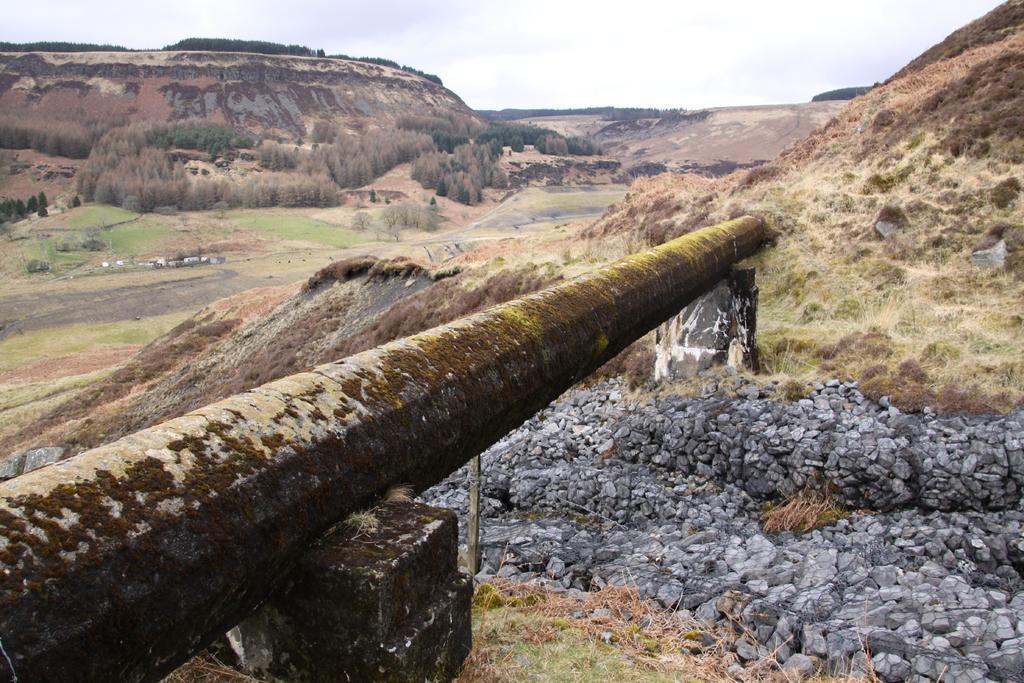Could you give a brief overview of what you see in this image? In this image we can see a hill. Image also consists of many trees. On the right there are concrete stones. At the top there is sky with clouds. 